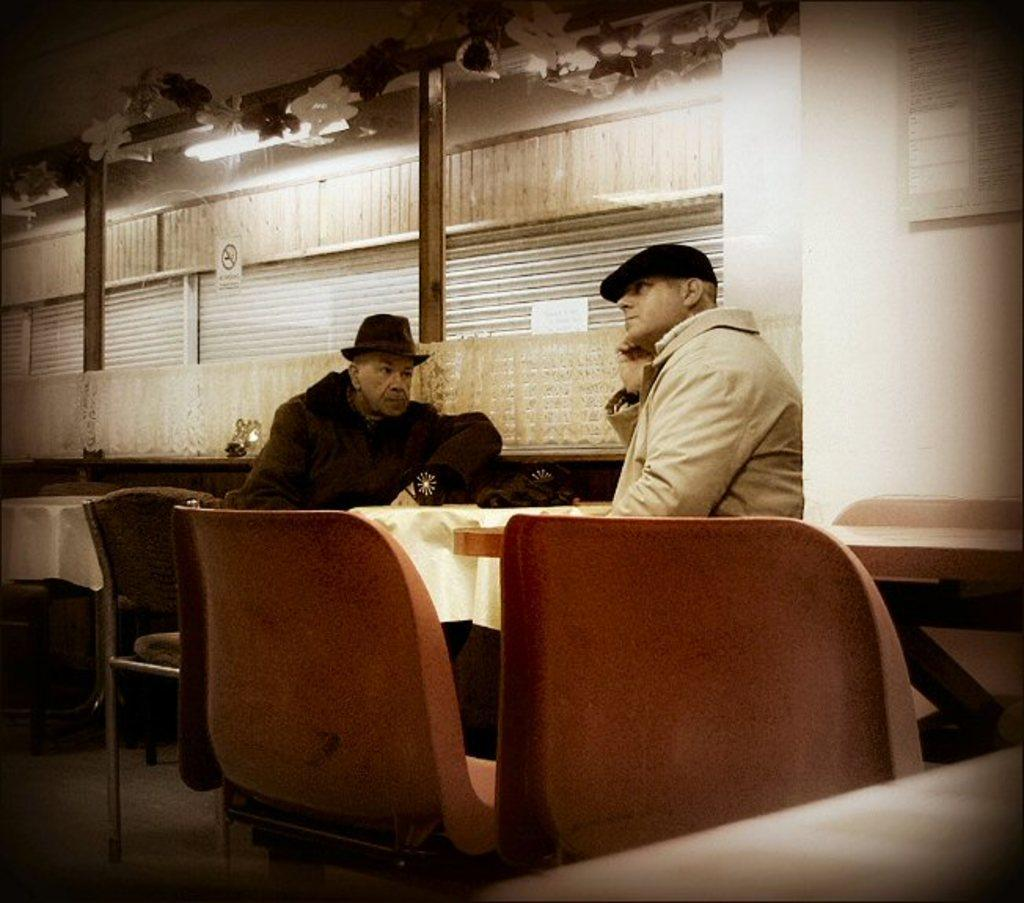How many people are in the image? There are two people in the image. What are the people doing in the image? The people are sitting on chairs. Where are the chairs and tables located? The chairs and tables are in a restaurant setting. What is in front of the people? There is a table in front of the people. How are the table and chairs arranged around the people? The table and chairs are arranged around the people. What can be seen beside the people? There is a wall beside the people. What sense is the governor using to read the calendar in the image? There is no governor or calendar present in the image. 